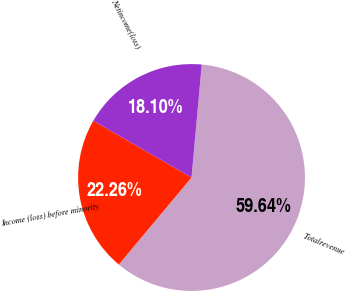Convert chart to OTSL. <chart><loc_0><loc_0><loc_500><loc_500><pie_chart><fcel>Totalrevenue<fcel>Income (loss) before minority<fcel>Netincome(loss)<nl><fcel>59.64%<fcel>22.26%<fcel>18.1%<nl></chart> 